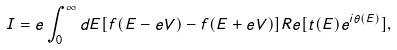<formula> <loc_0><loc_0><loc_500><loc_500>I = e \int _ { 0 } ^ { \infty } d E [ f ( E - e V ) - f ( E + e V ) ] R e [ t ( E ) e ^ { i \theta ( E ) } ] ,</formula> 